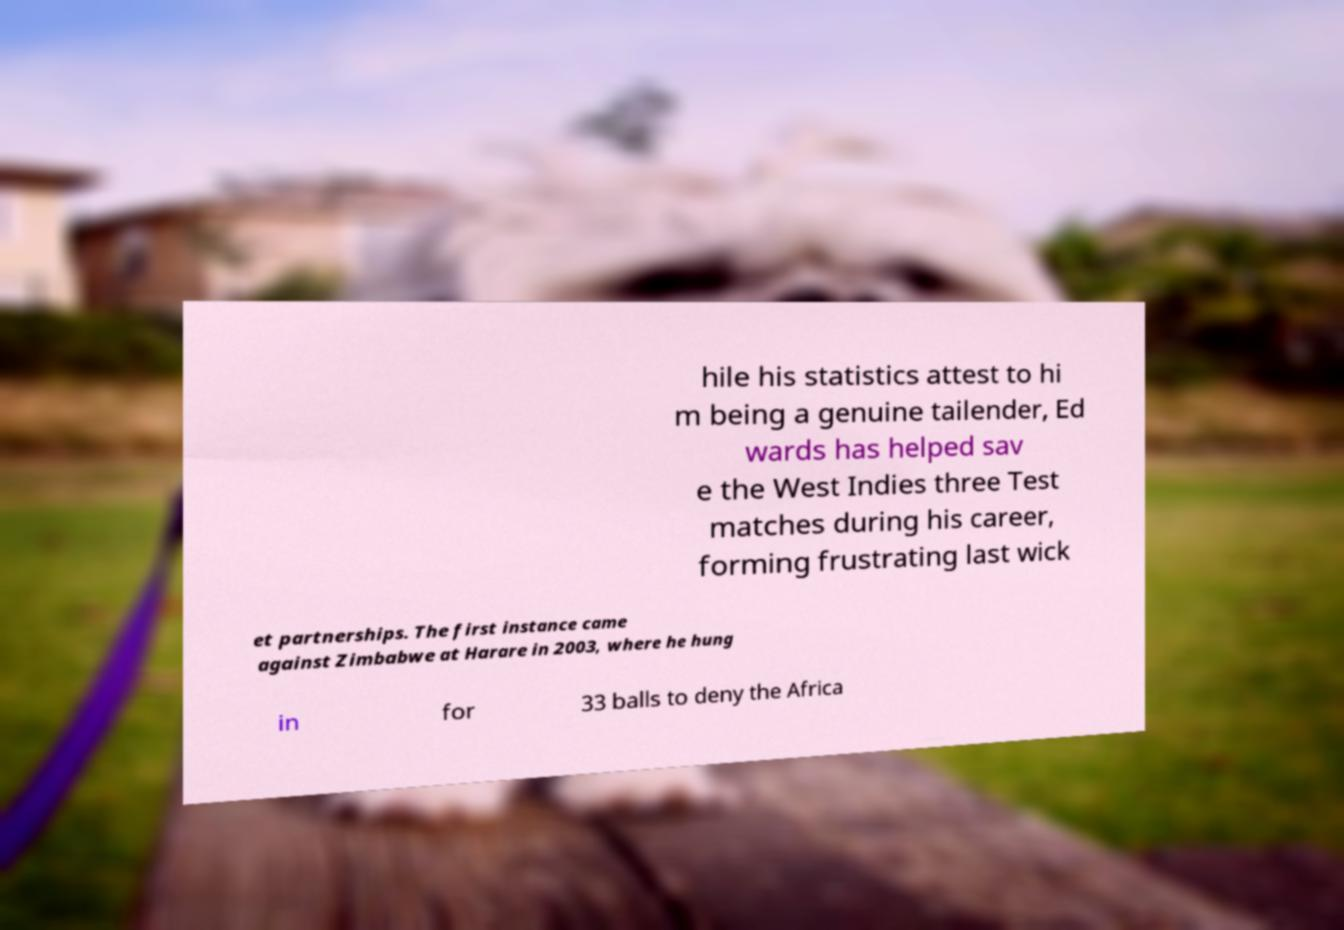There's text embedded in this image that I need extracted. Can you transcribe it verbatim? hile his statistics attest to hi m being a genuine tailender, Ed wards has helped sav e the West Indies three Test matches during his career, forming frustrating last wick et partnerships. The first instance came against Zimbabwe at Harare in 2003, where he hung in for 33 balls to deny the Africa 